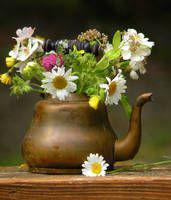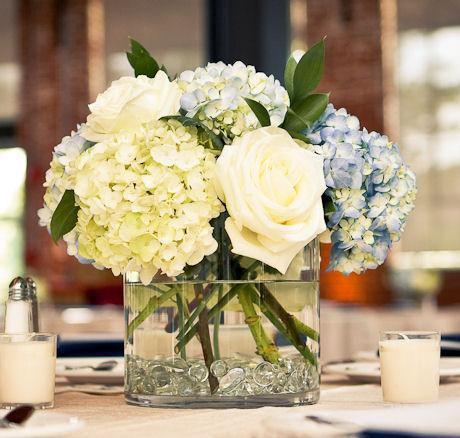The first image is the image on the left, the second image is the image on the right. Assess this claim about the two images: "There are flowers in a transparent vase in the image on the right.". Correct or not? Answer yes or no. Yes. 